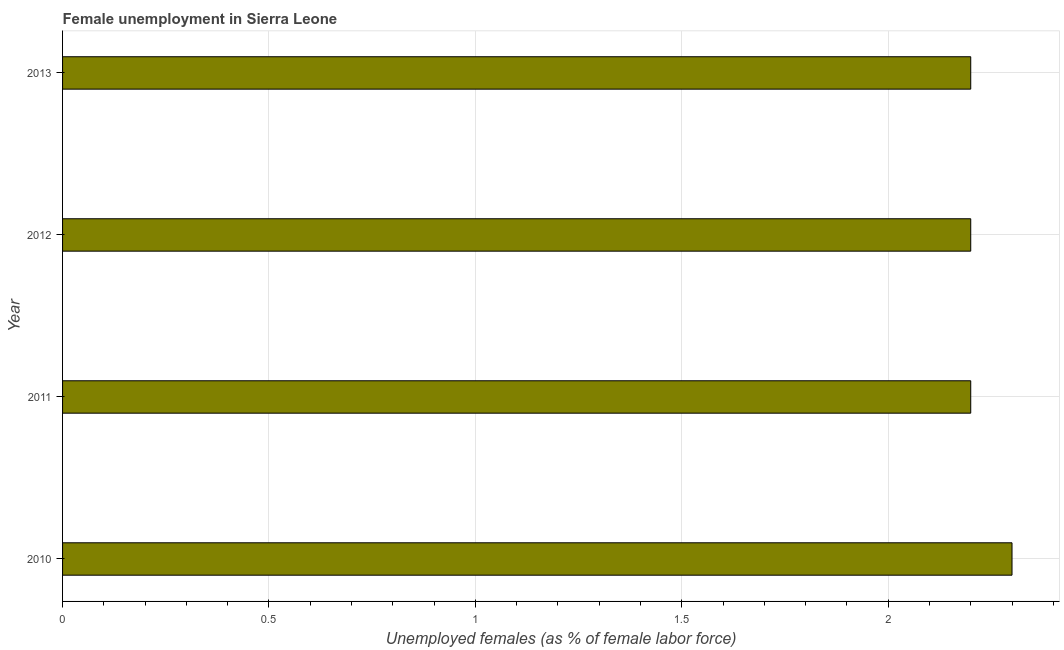Does the graph contain any zero values?
Provide a succinct answer. No. Does the graph contain grids?
Your answer should be very brief. Yes. What is the title of the graph?
Offer a terse response. Female unemployment in Sierra Leone. What is the label or title of the X-axis?
Keep it short and to the point. Unemployed females (as % of female labor force). What is the unemployed females population in 2013?
Make the answer very short. 2.2. Across all years, what is the maximum unemployed females population?
Ensure brevity in your answer.  2.3. Across all years, what is the minimum unemployed females population?
Ensure brevity in your answer.  2.2. In which year was the unemployed females population maximum?
Offer a terse response. 2010. In which year was the unemployed females population minimum?
Your response must be concise. 2011. What is the sum of the unemployed females population?
Provide a short and direct response. 8.9. What is the average unemployed females population per year?
Offer a very short reply. 2.23. What is the median unemployed females population?
Your answer should be compact. 2.2. Do a majority of the years between 2011 and 2013 (inclusive) have unemployed females population greater than 1.4 %?
Keep it short and to the point. Yes. In how many years, is the unemployed females population greater than the average unemployed females population taken over all years?
Your answer should be compact. 1. Are all the bars in the graph horizontal?
Your answer should be compact. Yes. Are the values on the major ticks of X-axis written in scientific E-notation?
Your answer should be very brief. No. What is the Unemployed females (as % of female labor force) in 2010?
Provide a succinct answer. 2.3. What is the Unemployed females (as % of female labor force) in 2011?
Ensure brevity in your answer.  2.2. What is the Unemployed females (as % of female labor force) in 2012?
Your answer should be very brief. 2.2. What is the Unemployed females (as % of female labor force) of 2013?
Your answer should be very brief. 2.2. What is the difference between the Unemployed females (as % of female labor force) in 2010 and 2011?
Offer a very short reply. 0.1. What is the difference between the Unemployed females (as % of female labor force) in 2010 and 2013?
Give a very brief answer. 0.1. What is the difference between the Unemployed females (as % of female labor force) in 2011 and 2012?
Provide a short and direct response. 0. What is the ratio of the Unemployed females (as % of female labor force) in 2010 to that in 2011?
Offer a terse response. 1.04. What is the ratio of the Unemployed females (as % of female labor force) in 2010 to that in 2012?
Keep it short and to the point. 1.04. What is the ratio of the Unemployed females (as % of female labor force) in 2010 to that in 2013?
Provide a short and direct response. 1.04. What is the ratio of the Unemployed females (as % of female labor force) in 2011 to that in 2012?
Give a very brief answer. 1. What is the ratio of the Unemployed females (as % of female labor force) in 2011 to that in 2013?
Make the answer very short. 1. What is the ratio of the Unemployed females (as % of female labor force) in 2012 to that in 2013?
Give a very brief answer. 1. 